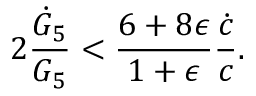<formula> <loc_0><loc_0><loc_500><loc_500>2 { \frac { \dot { G } _ { 5 } } { G _ { 5 } } } < { \frac { 6 + 8 \epsilon } { 1 + \epsilon } } { \frac { \dot { c } } { c } } .</formula> 